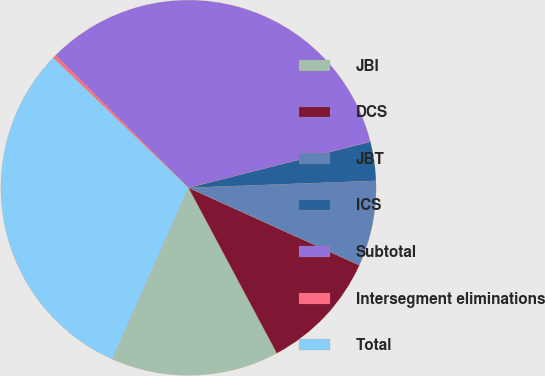Convert chart to OTSL. <chart><loc_0><loc_0><loc_500><loc_500><pie_chart><fcel>JBI<fcel>DCS<fcel>JBT<fcel>ICS<fcel>Subtotal<fcel>Intersegment eliminations<fcel>Total<nl><fcel>14.46%<fcel>10.42%<fcel>7.37%<fcel>3.35%<fcel>33.58%<fcel>0.3%<fcel>30.53%<nl></chart> 